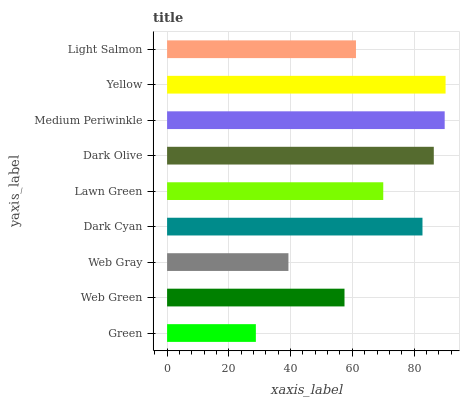Is Green the minimum?
Answer yes or no. Yes. Is Yellow the maximum?
Answer yes or no. Yes. Is Web Green the minimum?
Answer yes or no. No. Is Web Green the maximum?
Answer yes or no. No. Is Web Green greater than Green?
Answer yes or no. Yes. Is Green less than Web Green?
Answer yes or no. Yes. Is Green greater than Web Green?
Answer yes or no. No. Is Web Green less than Green?
Answer yes or no. No. Is Lawn Green the high median?
Answer yes or no. Yes. Is Lawn Green the low median?
Answer yes or no. Yes. Is Medium Periwinkle the high median?
Answer yes or no. No. Is Dark Cyan the low median?
Answer yes or no. No. 